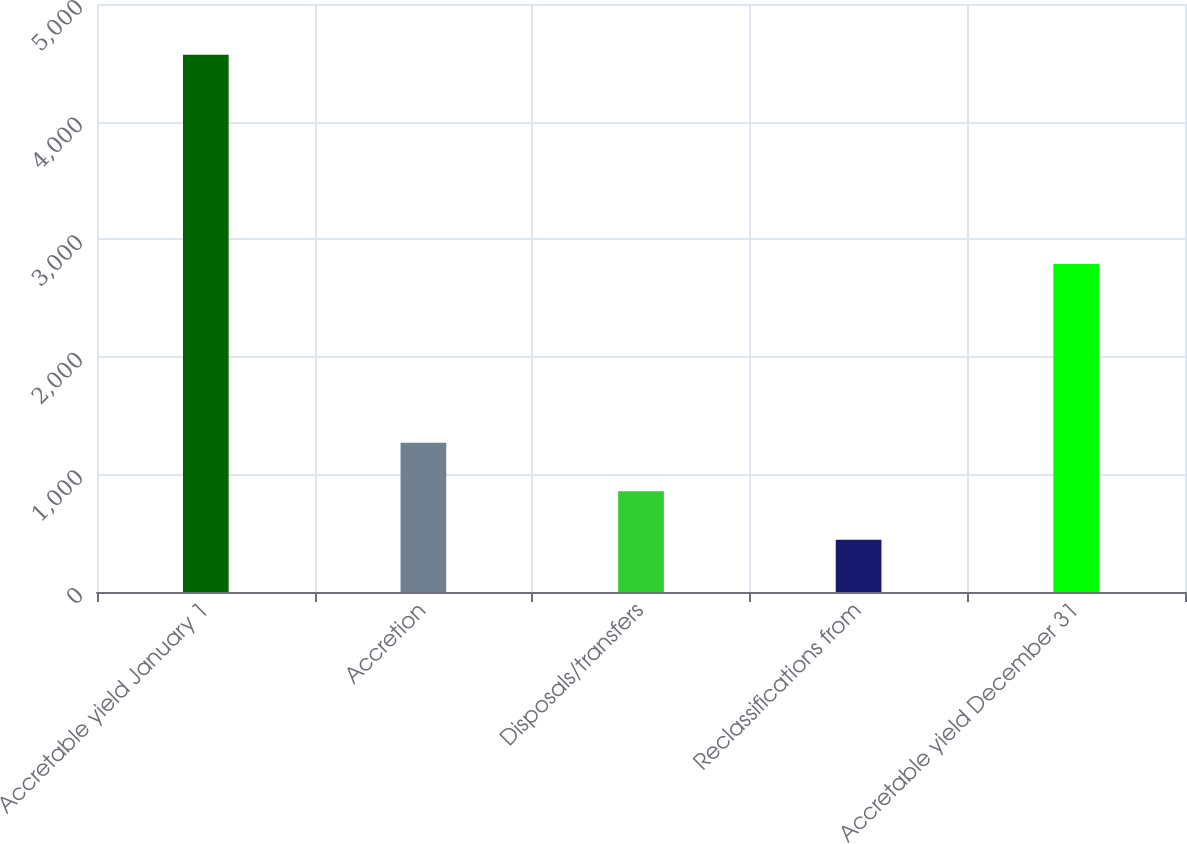<chart> <loc_0><loc_0><loc_500><loc_500><bar_chart><fcel>Accretable yield January 1<fcel>Accretion<fcel>Disposals/transfers<fcel>Reclassifications from<fcel>Accretable yield December 31<nl><fcel>4569<fcel>1269<fcel>856.5<fcel>444<fcel>2789<nl></chart> 